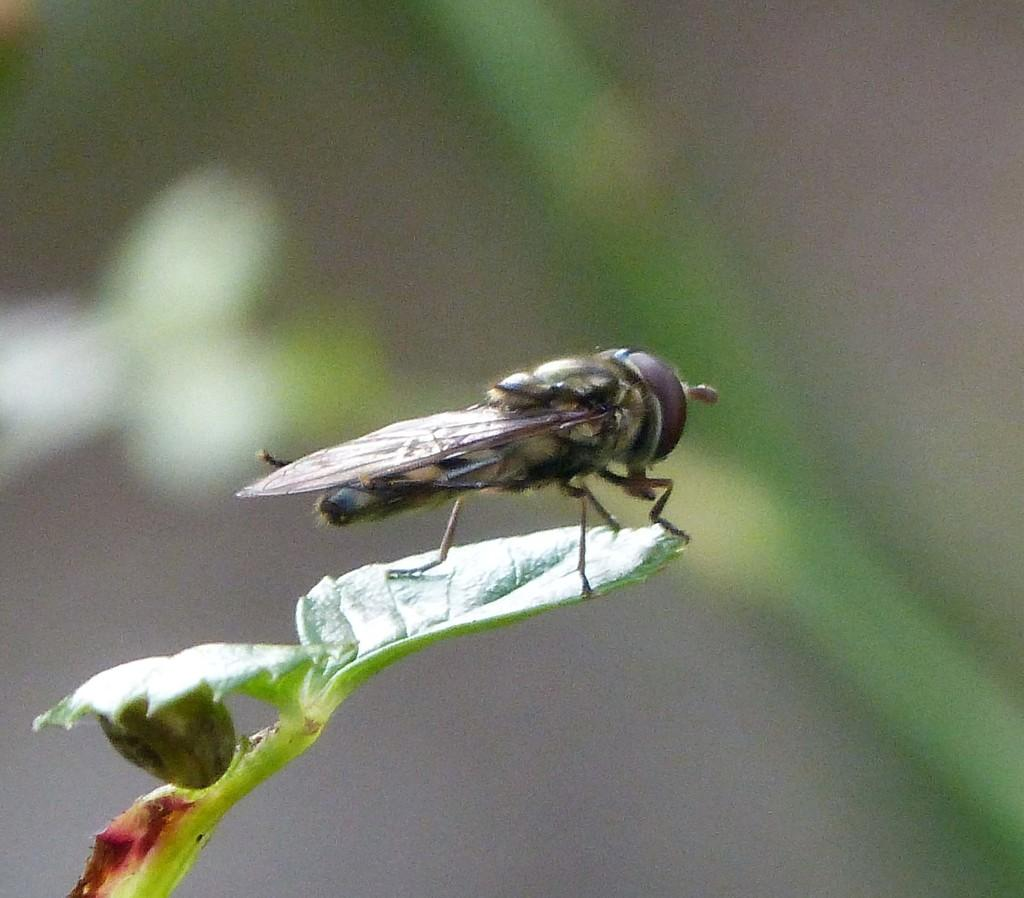What insect is present in the image? There is a house fly in the image. Where is the house fly located? The house fly is on the leaf of a plant. Can you see a snake slithering near the hydrant in the image? There is no snake or hydrant present in the image; it only features a house fly on a leaf. 